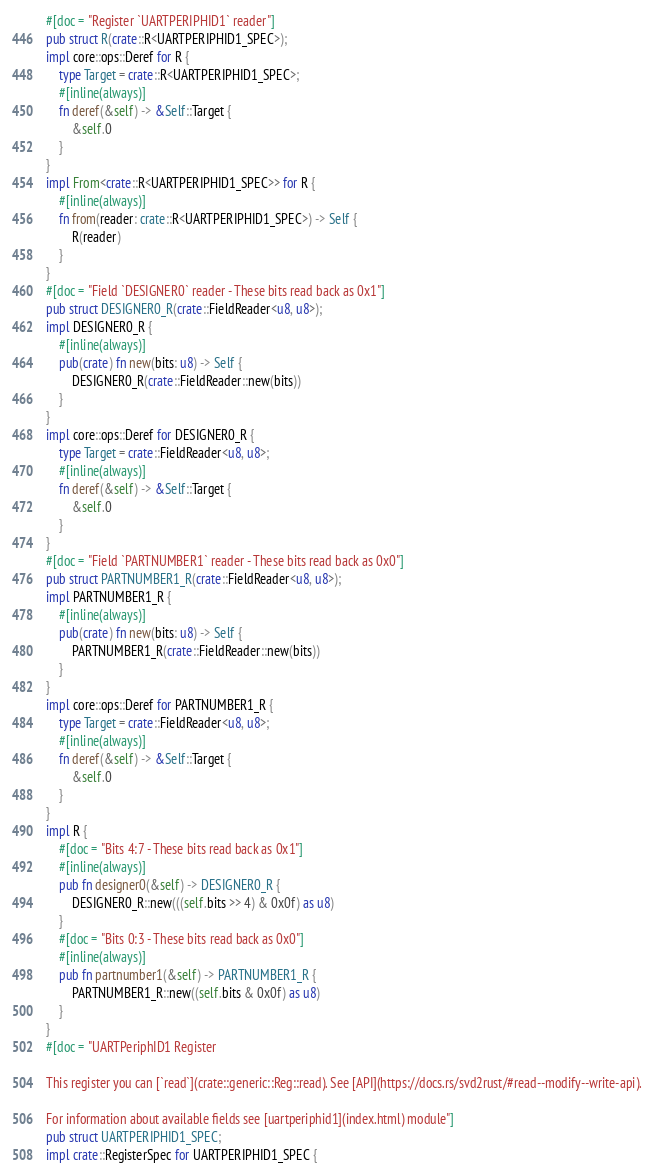Convert code to text. <code><loc_0><loc_0><loc_500><loc_500><_Rust_>#[doc = "Register `UARTPERIPHID1` reader"]
pub struct R(crate::R<UARTPERIPHID1_SPEC>);
impl core::ops::Deref for R {
    type Target = crate::R<UARTPERIPHID1_SPEC>;
    #[inline(always)]
    fn deref(&self) -> &Self::Target {
        &self.0
    }
}
impl From<crate::R<UARTPERIPHID1_SPEC>> for R {
    #[inline(always)]
    fn from(reader: crate::R<UARTPERIPHID1_SPEC>) -> Self {
        R(reader)
    }
}
#[doc = "Field `DESIGNER0` reader - These bits read back as 0x1"]
pub struct DESIGNER0_R(crate::FieldReader<u8, u8>);
impl DESIGNER0_R {
    #[inline(always)]
    pub(crate) fn new(bits: u8) -> Self {
        DESIGNER0_R(crate::FieldReader::new(bits))
    }
}
impl core::ops::Deref for DESIGNER0_R {
    type Target = crate::FieldReader<u8, u8>;
    #[inline(always)]
    fn deref(&self) -> &Self::Target {
        &self.0
    }
}
#[doc = "Field `PARTNUMBER1` reader - These bits read back as 0x0"]
pub struct PARTNUMBER1_R(crate::FieldReader<u8, u8>);
impl PARTNUMBER1_R {
    #[inline(always)]
    pub(crate) fn new(bits: u8) -> Self {
        PARTNUMBER1_R(crate::FieldReader::new(bits))
    }
}
impl core::ops::Deref for PARTNUMBER1_R {
    type Target = crate::FieldReader<u8, u8>;
    #[inline(always)]
    fn deref(&self) -> &Self::Target {
        &self.0
    }
}
impl R {
    #[doc = "Bits 4:7 - These bits read back as 0x1"]
    #[inline(always)]
    pub fn designer0(&self) -> DESIGNER0_R {
        DESIGNER0_R::new(((self.bits >> 4) & 0x0f) as u8)
    }
    #[doc = "Bits 0:3 - These bits read back as 0x0"]
    #[inline(always)]
    pub fn partnumber1(&self) -> PARTNUMBER1_R {
        PARTNUMBER1_R::new((self.bits & 0x0f) as u8)
    }
}
#[doc = "UARTPeriphID1 Register  

This register you can [`read`](crate::generic::Reg::read). See [API](https://docs.rs/svd2rust/#read--modify--write-api).  

For information about available fields see [uartperiphid1](index.html) module"]
pub struct UARTPERIPHID1_SPEC;
impl crate::RegisterSpec for UARTPERIPHID1_SPEC {</code> 